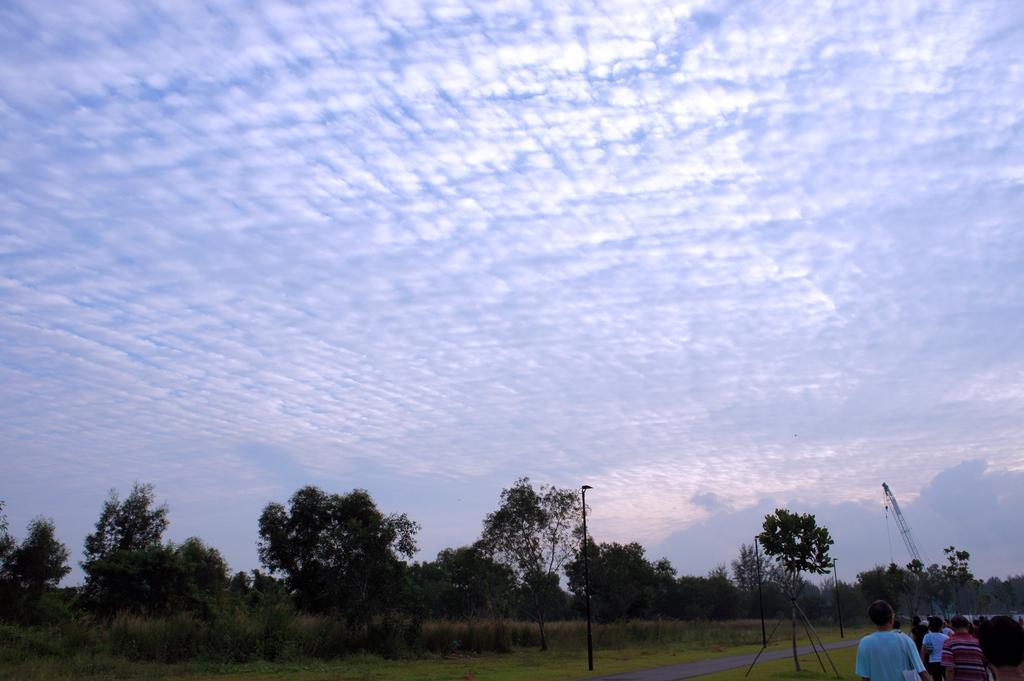Can you describe this image briefly? In this image we can see the road and some people standing. We can see the lights, grass and the trees. There are clouds in the sky. 